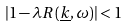Convert formula to latex. <formula><loc_0><loc_0><loc_500><loc_500>| 1 - \lambda R ( \underline { k } , \omega ) | < 1</formula> 